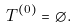Convert formula to latex. <formula><loc_0><loc_0><loc_500><loc_500>T ^ { ( 0 ) } = \emptyset .</formula> 